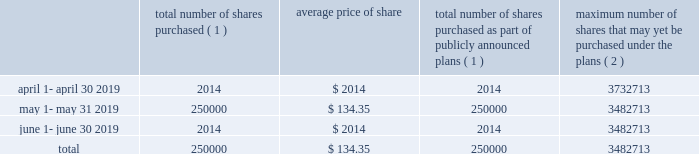J a c k h e n r y .
C o m 1 5 market for registrant 2019s common equity , related stockholder matters and issuer purchases of equity securities the company 2019s common stock is quoted on the nasdaq global select market ( 201cnasdaq 201d ) under the symbol 201cjkhy 201d .
The company established a practice of paying quarterly dividends at the end of fiscal 1990 and has paid dividends with respect to every quarter since that time .
The declaration and payment of any future dividends will continue to be at the discretion of our board of directors and will depend upon , among other factors , our earnings , capital requirements , contractual restrictions , and operating and financial condition .
The company does not currently foresee any changes in its dividend practices .
On august 15 , 2019 , there were approximately 145300 holders of the company 2019s common stock , including individual participants in security position listings .
On that same date the last sale price of the common shares as reported on nasdaq was $ 141.94 per share .
Issuer purchases of equity securities the following shares of the company were repurchased during the quarter ended june 30 , 2019 : total number of shares purchased ( 1 ) average price of total number of shares purchased as part of publicly announced plans ( 1 ) maximum number of shares that may yet be purchased under the plans ( 2 ) .
( 1 ) 250000 shares were purchased through a publicly announced repurchase plan .
There were no shares surrendered to the company to satisfy tax withholding obligations in connection with employee restricted stock awards .
( 2 ) total stock repurchase authorizations approved by the company 2019s board of directors as of february 17 , 2015 were for 30.0 million shares .
These authorizations have no specific dollar or share price targets and no expiration dates. .
What was the percentage of the shares purchase of the maximum number of shares that may yet be purchased under the plans? 
Computations: (250000 / 3482713)
Answer: 0.07178. 